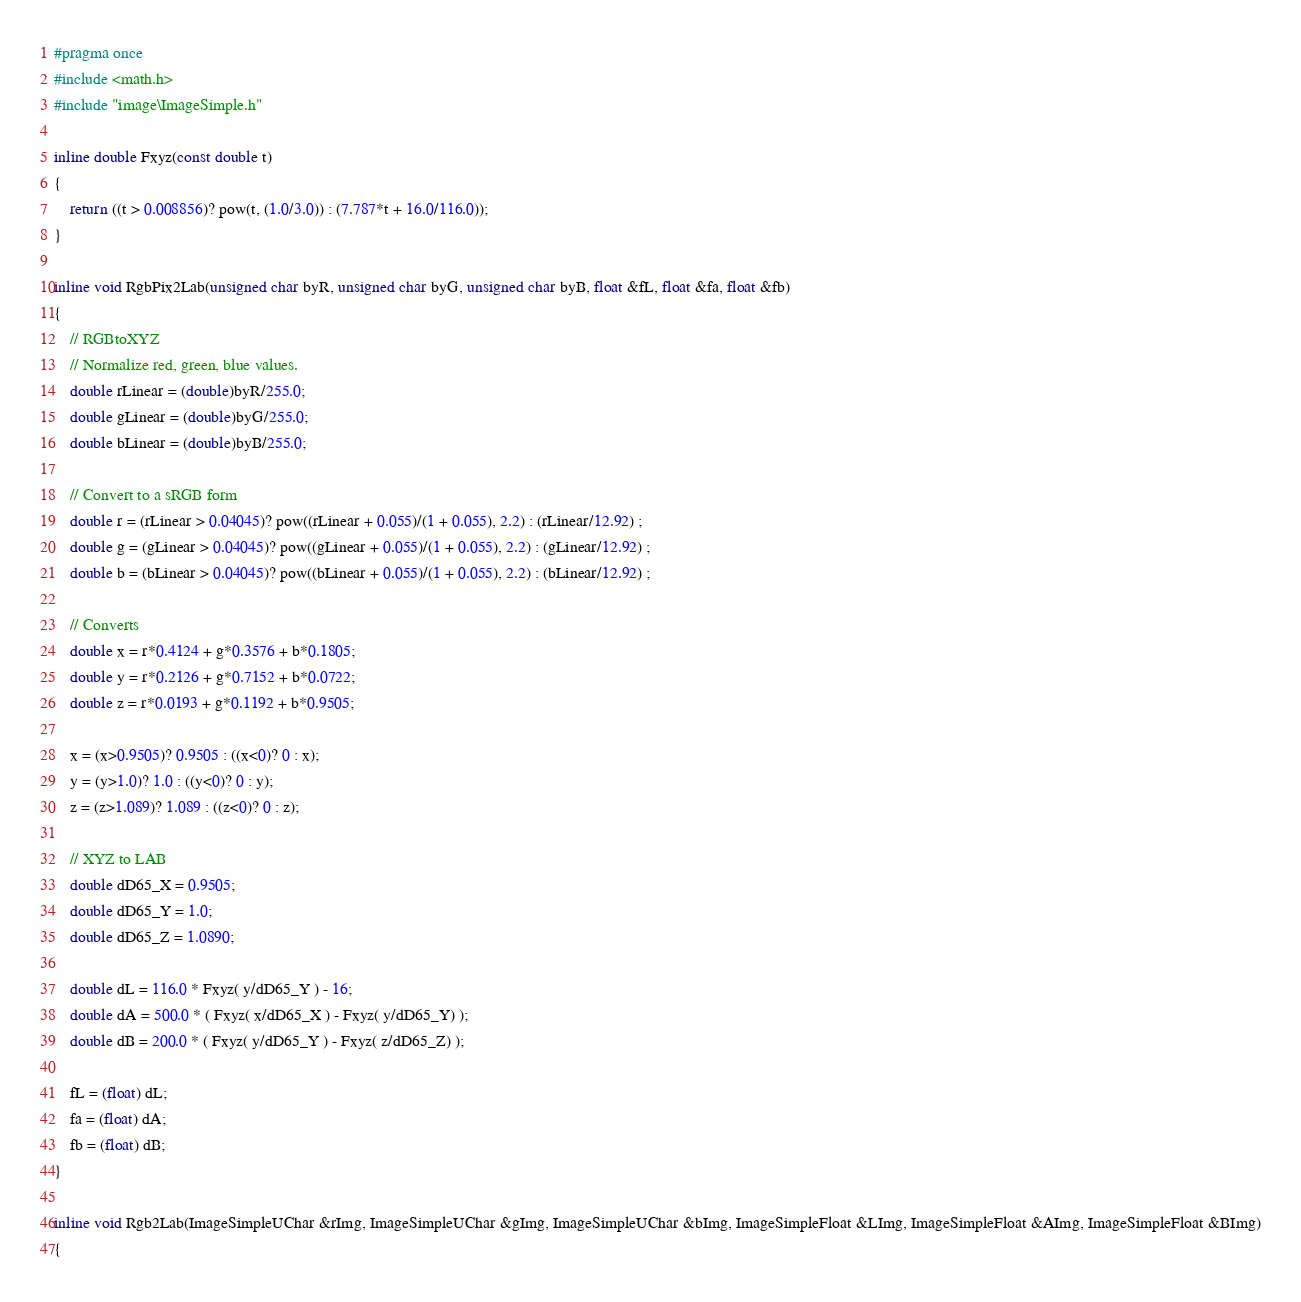<code> <loc_0><loc_0><loc_500><loc_500><_C_>#pragma once    
#include <math.h>
#include "image\ImageSimple.h"

inline double Fxyz(const double t)
{
    return ((t > 0.008856)? pow(t, (1.0/3.0)) : (7.787*t + 16.0/116.0));
}

inline void RgbPix2Lab(unsigned char byR, unsigned char byG, unsigned char byB, float &fL, float &fa, float &fb)
{
    // RGBtoXYZ		
    // Normalize red, green, blue values.
    double rLinear = (double)byR/255.0;
    double gLinear = (double)byG/255.0;
    double bLinear = (double)byB/255.0;

    // Convert to a sRGB form
    double r = (rLinear > 0.04045)? pow((rLinear + 0.055)/(1 + 0.055), 2.2) : (rLinear/12.92) ;
    double g = (gLinear > 0.04045)? pow((gLinear + 0.055)/(1 + 0.055), 2.2) : (gLinear/12.92) ;
    double b = (bLinear > 0.04045)? pow((bLinear + 0.055)/(1 + 0.055), 2.2) : (bLinear/12.92) ;

    // Converts
    double x = r*0.4124 + g*0.3576 + b*0.1805;
    double y = r*0.2126 + g*0.7152 + b*0.0722;
    double z = r*0.0193 + g*0.1192 + b*0.9505;

    x = (x>0.9505)? 0.9505 : ((x<0)? 0 : x);
    y = (y>1.0)? 1.0 : ((y<0)? 0 : y);
    z = (z>1.089)? 1.089 : ((z<0)? 0 : z);

    // XYZ to LAB
    double dD65_X = 0.9505;
    double dD65_Y = 1.0;
    double dD65_Z = 1.0890;

    double dL = 116.0 * Fxyz( y/dD65_Y ) - 16;
    double dA = 500.0 * ( Fxyz( x/dD65_X ) - Fxyz( y/dD65_Y) );
    double dB = 200.0 * ( Fxyz( y/dD65_Y ) - Fxyz( z/dD65_Z) );

    fL = (float) dL;
    fa = (float) dA;
    fb = (float) dB;
}

inline void Rgb2Lab(ImageSimpleUChar &rImg, ImageSimpleUChar &gImg, ImageSimpleUChar &bImg, ImageSimpleFloat &LImg, ImageSimpleFloat &AImg, ImageSimpleFloat &BImg)
{</code> 